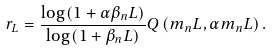Convert formula to latex. <formula><loc_0><loc_0><loc_500><loc_500>r _ { L } = \frac { \log \left ( 1 + \alpha \beta _ { n } L \right ) } { \log \left ( 1 + \beta _ { n } L \right ) } Q \left ( m _ { n } L , \alpha m _ { n } L \right ) .</formula> 